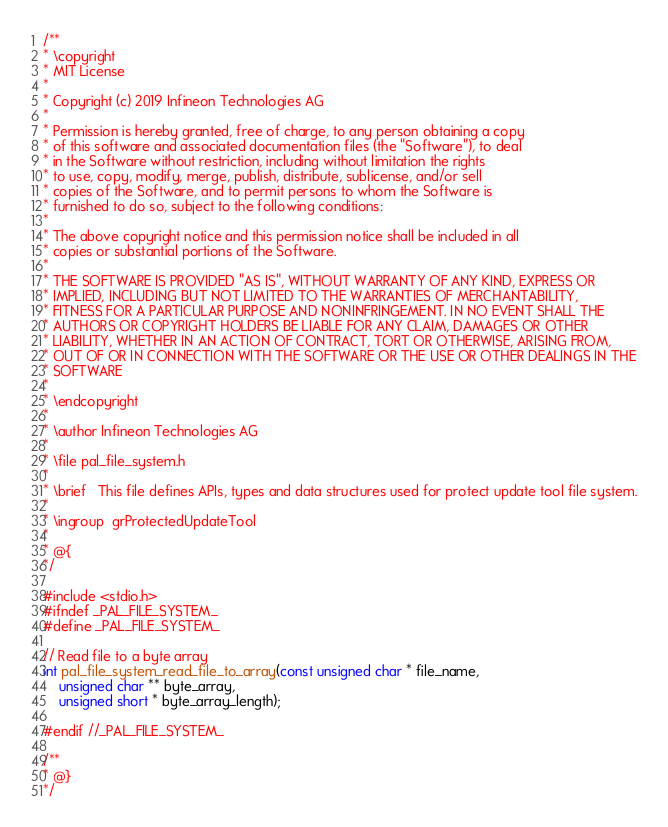<code> <loc_0><loc_0><loc_500><loc_500><_C_>/**
* \copyright
* MIT License
*
* Copyright (c) 2019 Infineon Technologies AG
*
* Permission is hereby granted, free of charge, to any person obtaining a copy
* of this software and associated documentation files (the "Software"), to deal
* in the Software without restriction, including without limitation the rights
* to use, copy, modify, merge, publish, distribute, sublicense, and/or sell
* copies of the Software, and to permit persons to whom the Software is
* furnished to do so, subject to the following conditions:
*
* The above copyright notice and this permission notice shall be included in all
* copies or substantial portions of the Software.
*
* THE SOFTWARE IS PROVIDED "AS IS", WITHOUT WARRANTY OF ANY KIND, EXPRESS OR
* IMPLIED, INCLUDING BUT NOT LIMITED TO THE WARRANTIES OF MERCHANTABILITY,
* FITNESS FOR A PARTICULAR PURPOSE AND NONINFRINGEMENT. IN NO EVENT SHALL THE
* AUTHORS OR COPYRIGHT HOLDERS BE LIABLE FOR ANY CLAIM, DAMAGES OR OTHER
* LIABILITY, WHETHER IN AN ACTION OF CONTRACT, TORT OR OTHERWISE, ARISING FROM,
* OUT OF OR IN CONNECTION WITH THE SOFTWARE OR THE USE OR OTHER DEALINGS IN THE
* SOFTWARE
*
* \endcopyright
*
* \author Infineon Technologies AG
*
* \file pal_file_system.h
*
* \brief   This file defines APIs, types and data structures used for protect update tool file system.
*
* \ingroup  grProtectedUpdateTool
*
* @{
*/

#include <stdio.h>
#ifndef _PAL_FILE_SYSTEM_
#define _PAL_FILE_SYSTEM_

// Read file to a byte array
int pal_file_system_read_file_to_array(const unsigned char * file_name,
	unsigned char ** byte_array,
	unsigned short * byte_array_length);

#endif //_PAL_FILE_SYSTEM_

/**
* @}
*/</code> 